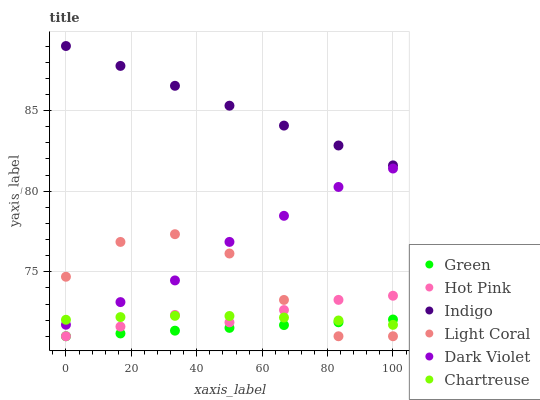Does Green have the minimum area under the curve?
Answer yes or no. Yes. Does Indigo have the maximum area under the curve?
Answer yes or no. Yes. Does Hot Pink have the minimum area under the curve?
Answer yes or no. No. Does Hot Pink have the maximum area under the curve?
Answer yes or no. No. Is Green the smoothest?
Answer yes or no. Yes. Is Light Coral the roughest?
Answer yes or no. Yes. Is Hot Pink the smoothest?
Answer yes or no. No. Is Hot Pink the roughest?
Answer yes or no. No. Does Hot Pink have the lowest value?
Answer yes or no. Yes. Does Dark Violet have the lowest value?
Answer yes or no. No. Does Indigo have the highest value?
Answer yes or no. Yes. Does Hot Pink have the highest value?
Answer yes or no. No. Is Green less than Indigo?
Answer yes or no. Yes. Is Indigo greater than Dark Violet?
Answer yes or no. Yes. Does Light Coral intersect Hot Pink?
Answer yes or no. Yes. Is Light Coral less than Hot Pink?
Answer yes or no. No. Is Light Coral greater than Hot Pink?
Answer yes or no. No. Does Green intersect Indigo?
Answer yes or no. No. 